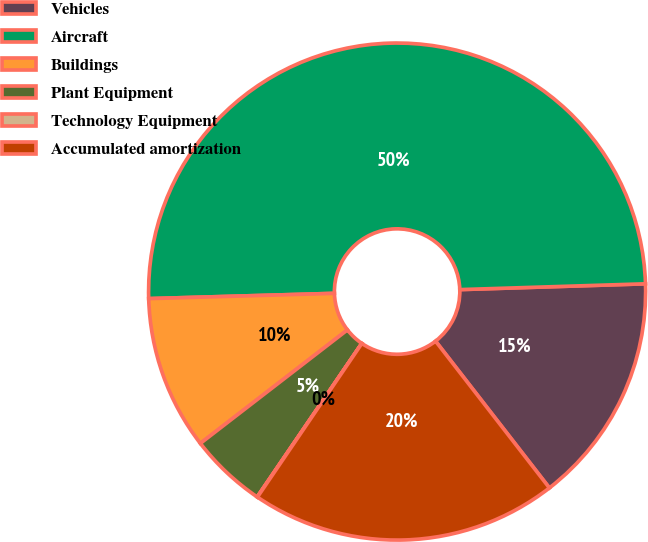Convert chart to OTSL. <chart><loc_0><loc_0><loc_500><loc_500><pie_chart><fcel>Vehicles<fcel>Aircraft<fcel>Buildings<fcel>Plant Equipment<fcel>Technology Equipment<fcel>Accumulated amortization<nl><fcel>15.0%<fcel>49.96%<fcel>10.01%<fcel>5.02%<fcel>0.02%<fcel>20.0%<nl></chart> 